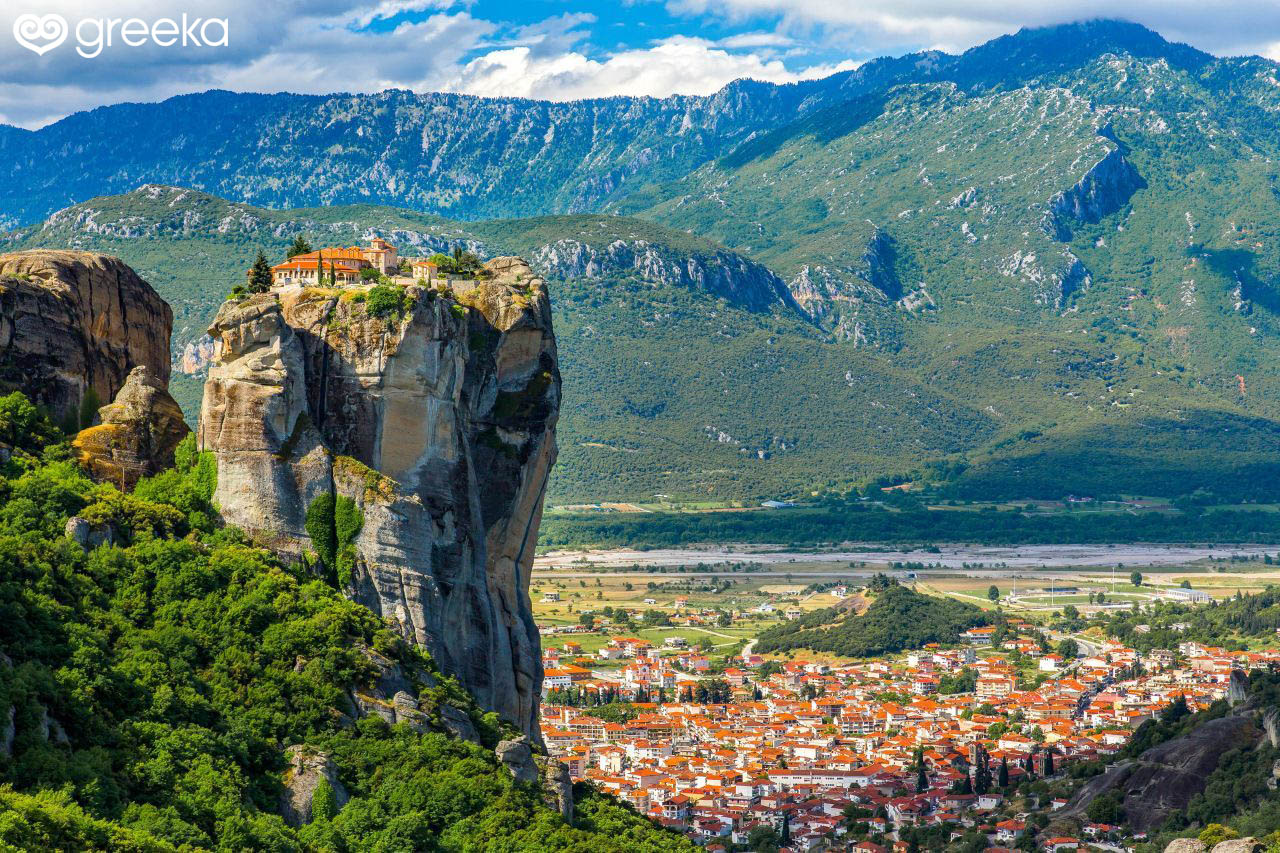What kind of creative project could be inspired by this image? This stunning image could inspire a variety of creative projects. One idea could be a graphic novel or fantasy story set in an ancient, mystical world where these towering rock formations serve as homes to wizards, monks, or even a reclusive order of guardians of ancient knowledge. Alternatively, an art installation could be created, using vertical canvases to mimic the scale of the rock formations, incorporating mixed media like stone, paint, and vegetation to capture the texture and color of the landscape. A photography series could delve into the lives and stories of the people who reside in the town below, capturing the harmony between the natural and built environments. 